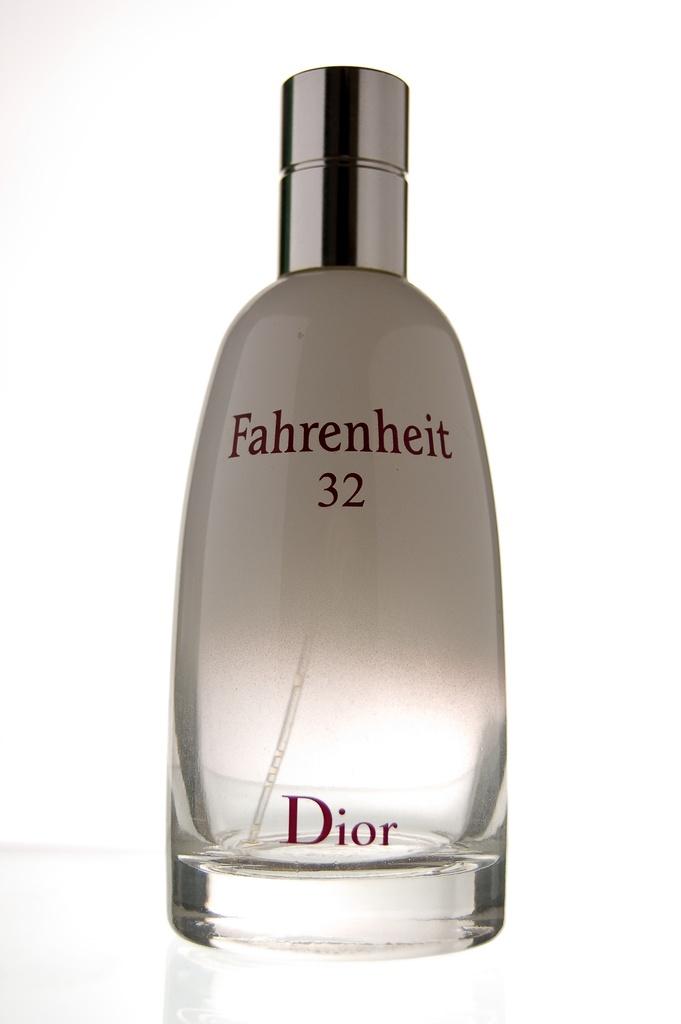What is the name of this dior perfume?
Your response must be concise. Fahrenheit 32. What company made the perfume?
Your response must be concise. Dior. 